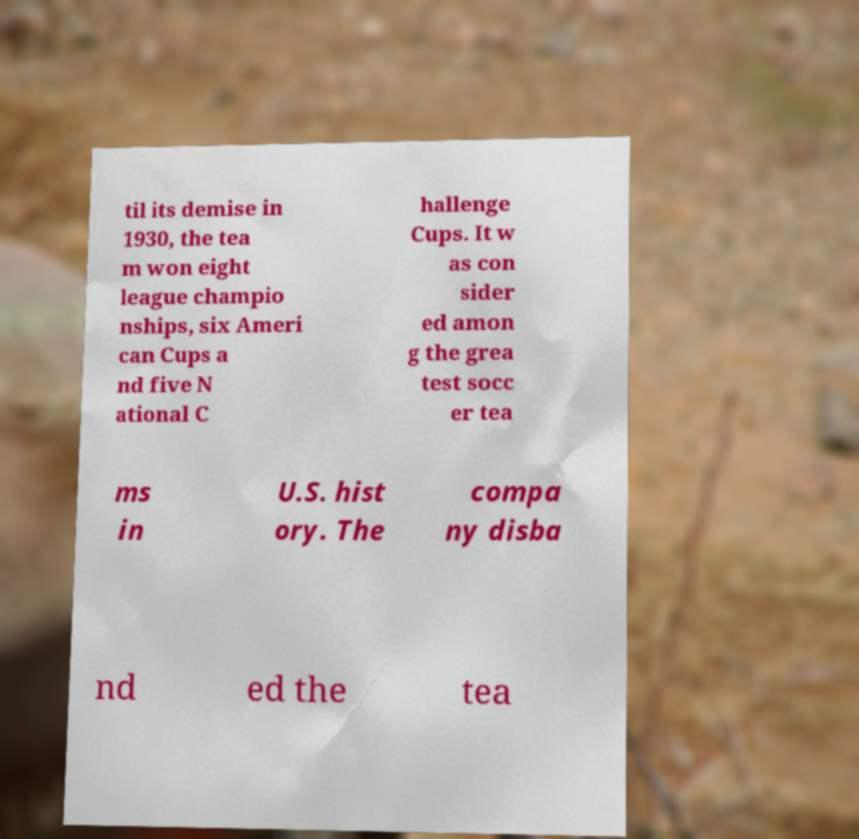Can you accurately transcribe the text from the provided image for me? til its demise in 1930, the tea m won eight league champio nships, six Ameri can Cups a nd five N ational C hallenge Cups. It w as con sider ed amon g the grea test socc er tea ms in U.S. hist ory. The compa ny disba nd ed the tea 